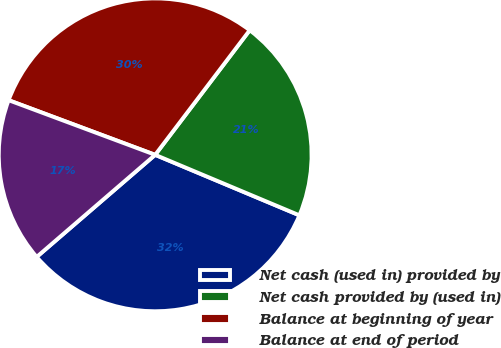Convert chart. <chart><loc_0><loc_0><loc_500><loc_500><pie_chart><fcel>Net cash (used in) provided by<fcel>Net cash provided by (used in)<fcel>Balance at beginning of year<fcel>Balance at end of period<nl><fcel>32.36%<fcel>20.99%<fcel>29.65%<fcel>17.0%<nl></chart> 